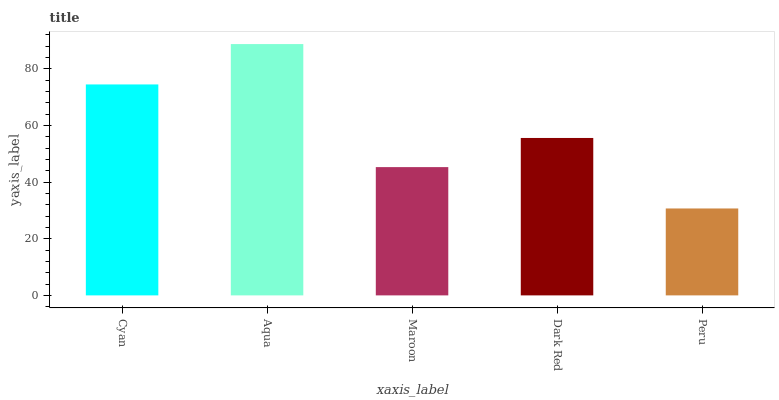Is Maroon the minimum?
Answer yes or no. No. Is Maroon the maximum?
Answer yes or no. No. Is Aqua greater than Maroon?
Answer yes or no. Yes. Is Maroon less than Aqua?
Answer yes or no. Yes. Is Maroon greater than Aqua?
Answer yes or no. No. Is Aqua less than Maroon?
Answer yes or no. No. Is Dark Red the high median?
Answer yes or no. Yes. Is Dark Red the low median?
Answer yes or no. Yes. Is Peru the high median?
Answer yes or no. No. Is Maroon the low median?
Answer yes or no. No. 